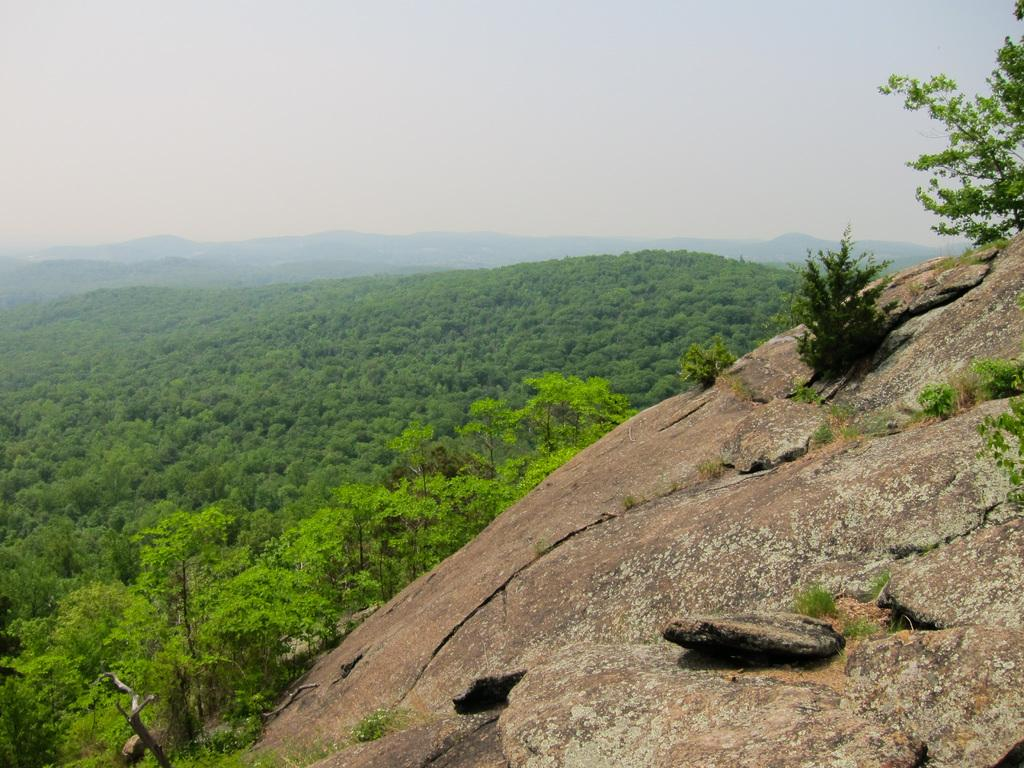What type of landform is present in the image? There is a hill in the image. What can be found under the hill? There are many trees under the hill. What can be seen in the distance behind the hill? There are mountains visible in the background of the image. What type of vegetable is growing on the hill in the image? There is no vegetable growing on the hill in the image; it is covered with trees. 